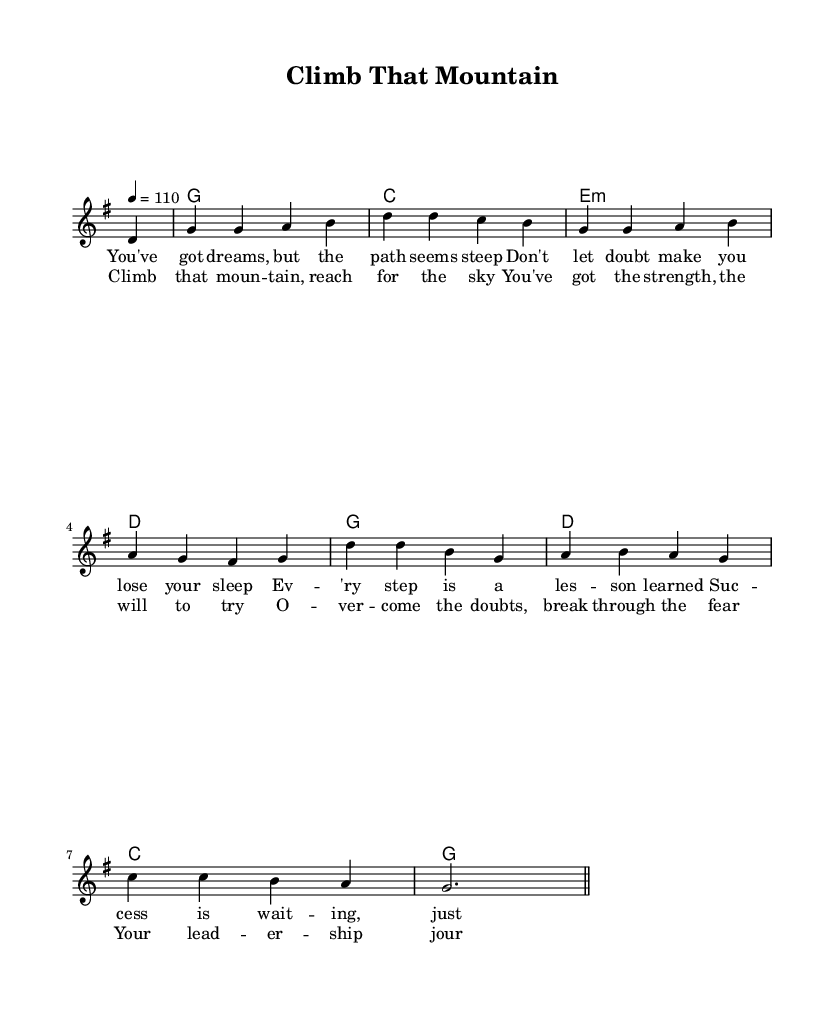What is the key signature of this music? The key signature is G major, which has one sharp (F#). This can be identified by looking for the number of sharps or flats at the beginning of the staff.
Answer: G major What is the time signature of this piece? The time signature is 4/4, indicated by the notation at the beginning of the staff. This means there are four beats per measure, and the quarter note gets one beat.
Answer: 4/4 What is the tempo marking for this song? The tempo marking is 110 beats per minute, as shown in the tempo indication near the top of the score. This indicates how fast the music should be played.
Answer: 110 How many lines are in the melody? The melody consists of two lines. This can be determined by counting the distinct phrases or groupings of notes in the staff.
Answer: Two lines Which chords appear in the harmony section? The chords in the harmony section are G, C, E minor, and D. This is found by looking at the chord symbols placed above the staff in the harmony section.
Answer: G, C, E minor, D What theme is explored in the lyrics? The theme explores overcoming obstacles and pursuing leadership. By analyzing the lyrics, phrases about dreams, doubts, and leadership journeys illustrate this inspirational narrative.
Answer: Overcoming obstacles What is the structure of the song based on the lyrics? The song has a verse-chorus structure. The first part consists of a verse followed by a repeated chorus, which is a common structure in country rock songs, making the message easily memorable.
Answer: Verse-chorus 